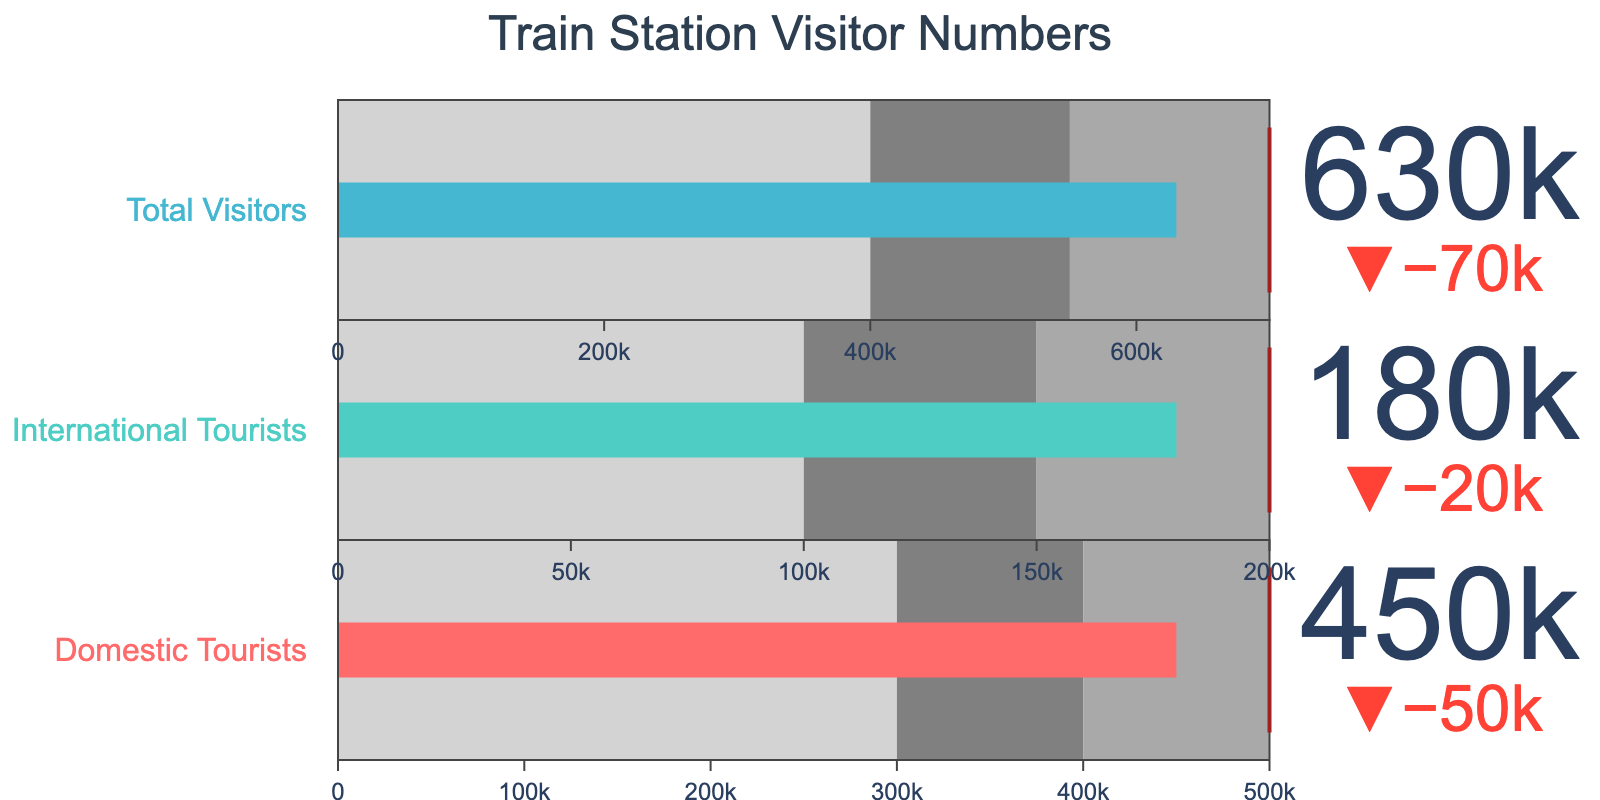What's the total target number of visitors? The bullet chart displays the target numbers for different categories. Summing up the targets for Domestic Tourists (500,000) and International Tourists (200,000) gives the total target of visitors.
Answer: 700,000 Which category surpassed the shaded 'dark gray' region? The 'dark gray' regions represent the range leading up to the targets for each category. Comparing the 'Actual' values to the 'Range3' values, none of the bars surpass the 'dark gray' zones as neither category met their targets.
Answer: None How many visitors less did the station need to achieve its domestic target? The actual number of domestic tourists is given as 450,000, and the target is 500,000. Subtracting the actual from the target, 500,000 - 450,000 = 50,000.
Answer: 50,000 Is the shortfall larger for domestic tourists or international tourists? For domestic tourists, the shortfall is 50,000 (500,000 - 450,000). For international tourists, the shortfall is 20,000 (200,000 - 180,000). Comparing the values, the shortfall is larger for domestic tourists.
Answer: Domestic tourists What's the proportion of international tourists among the total visitors? The actual total visitors are 630,000, and international tourists are 180,000. The proportion is calculated as 180,000 / 630,000 which simplifies to approximately 28.57%.
Answer: 28.57% Which category is closer to its target in relative terms? Calculate the percentage of actual to target for both categories. Domestic tourists: (450,000 / 500,000) * 100 = 90%. International tourists: (180,000 / 200,000) * 100 = 90%. Both categories are equally close to their targets in relative terms at 90% each.
Answer: Both are equally close What's the average number of visitors in the 'dark gray' ranges? For domestic tourists, 'dark gray' ranges from 400,000 to 500,000, giving an average of (400,000 + 500,000) / 2 = 450,000. For international tourists, the 'dark gray' range is 150,000 to 200,000, giving an average of (150,000 + 200,000) / 2 = 175,000. The total average is (450,000 + 175,000) / 2 = 312,500.
Answer: 312,500 